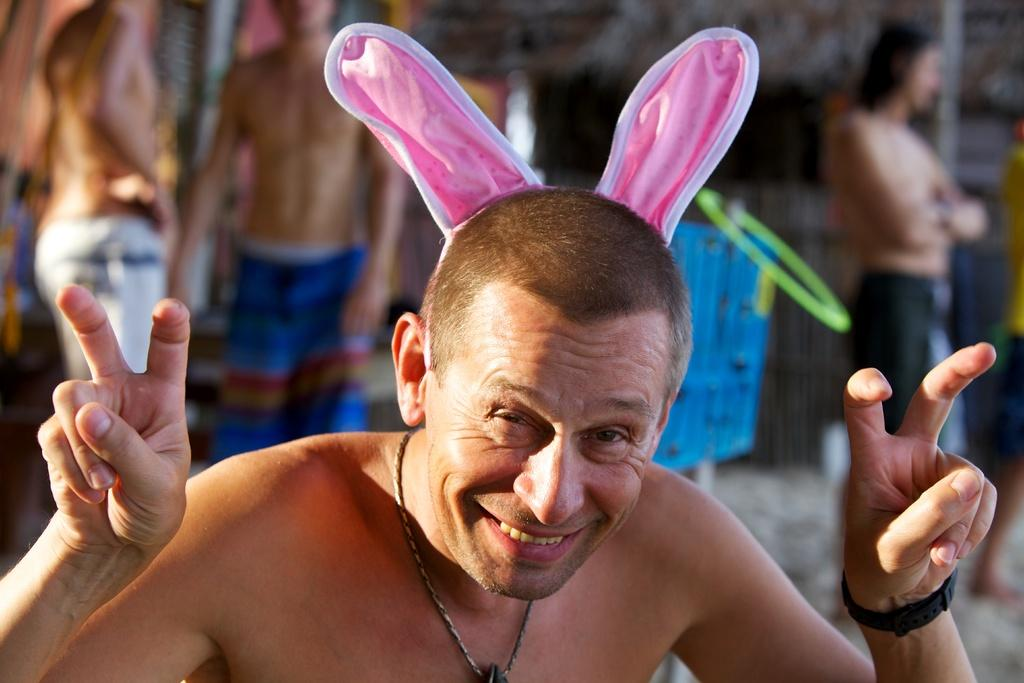Who is the main subject in the image? There is a man in the image. What is the man doing with his fingers? The man is showing his fingers in the image. What is the man wearing on his head? The man is wearing a pink cloth on his head. What type of grain is being served in the image? There is no grain present in the image; it features a man showing his fingers and wearing a pink cloth on his head. What emotion is the man expressing in the image? The emotion of the man cannot be determined from the image, as it only shows him showing his fingers and wearing a pink cloth on his head. 